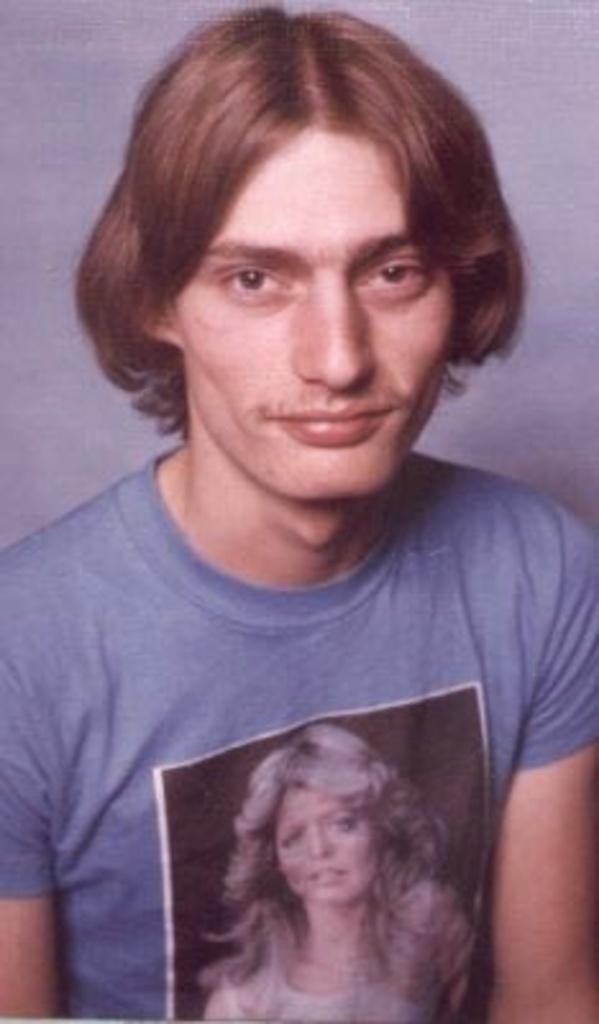Who is present in the image? There is a man in the picture. What is the man wearing in the image? The man is wearing a T-shirt. What can be seen on the T-shirt? There is a photo of a woman on the T-shirt. What type of winter board activity is the man participating in the image? There is no indication of any winter board activity in the image; the man is simply wearing a T-shirt with a photo of a woman. How many cars can be seen in the image? There are no cars present in the image. 